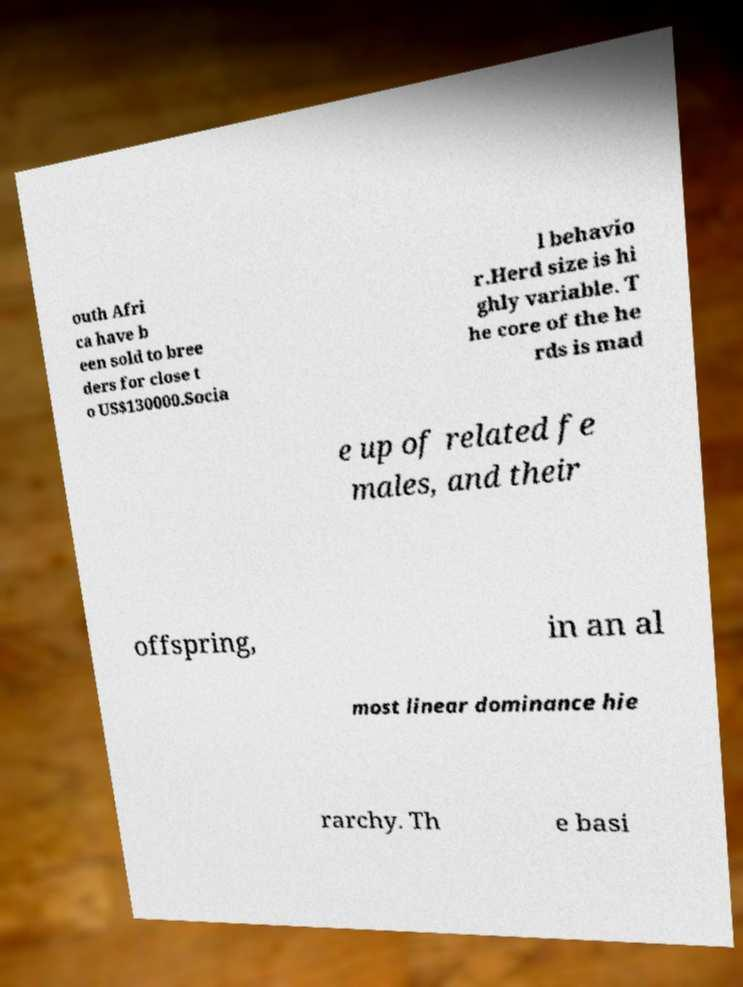Can you read and provide the text displayed in the image?This photo seems to have some interesting text. Can you extract and type it out for me? outh Afri ca have b een sold to bree ders for close t o US$130000.Socia l behavio r.Herd size is hi ghly variable. T he core of the he rds is mad e up of related fe males, and their offspring, in an al most linear dominance hie rarchy. Th e basi 